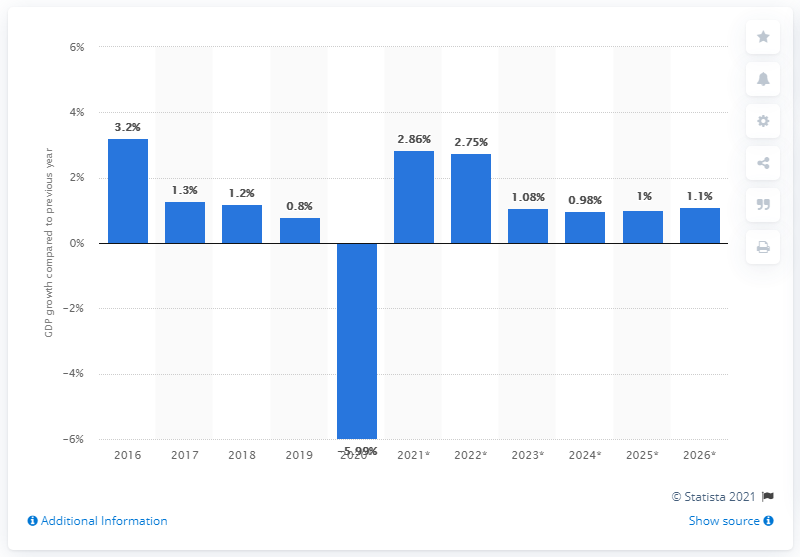Specify some key components in this picture. According to the information available, Algeria's real GDP increased by 0.8% in 2019. 